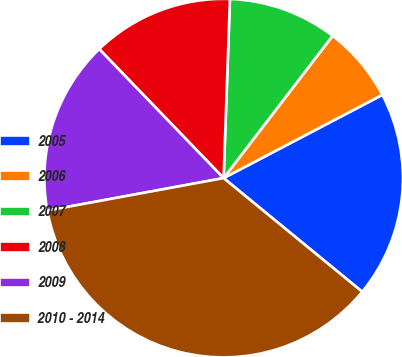Convert chart. <chart><loc_0><loc_0><loc_500><loc_500><pie_chart><fcel>2005<fcel>2006<fcel>2007<fcel>2008<fcel>2009<fcel>2010 - 2014<nl><fcel>18.62%<fcel>6.91%<fcel>9.84%<fcel>12.77%<fcel>15.69%<fcel>36.17%<nl></chart> 